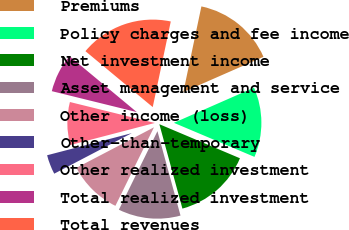Convert chart to OTSL. <chart><loc_0><loc_0><loc_500><loc_500><pie_chart><fcel>Premiums<fcel>Policy charges and fee income<fcel>Net investment income<fcel>Asset management and service<fcel>Other income (loss)<fcel>Other-than-temporary<fcel>Other realized investment<fcel>Total realized investment<fcel>Total revenues<nl><fcel>15.11%<fcel>12.95%<fcel>14.39%<fcel>11.51%<fcel>10.07%<fcel>3.6%<fcel>7.91%<fcel>7.19%<fcel>17.27%<nl></chart> 